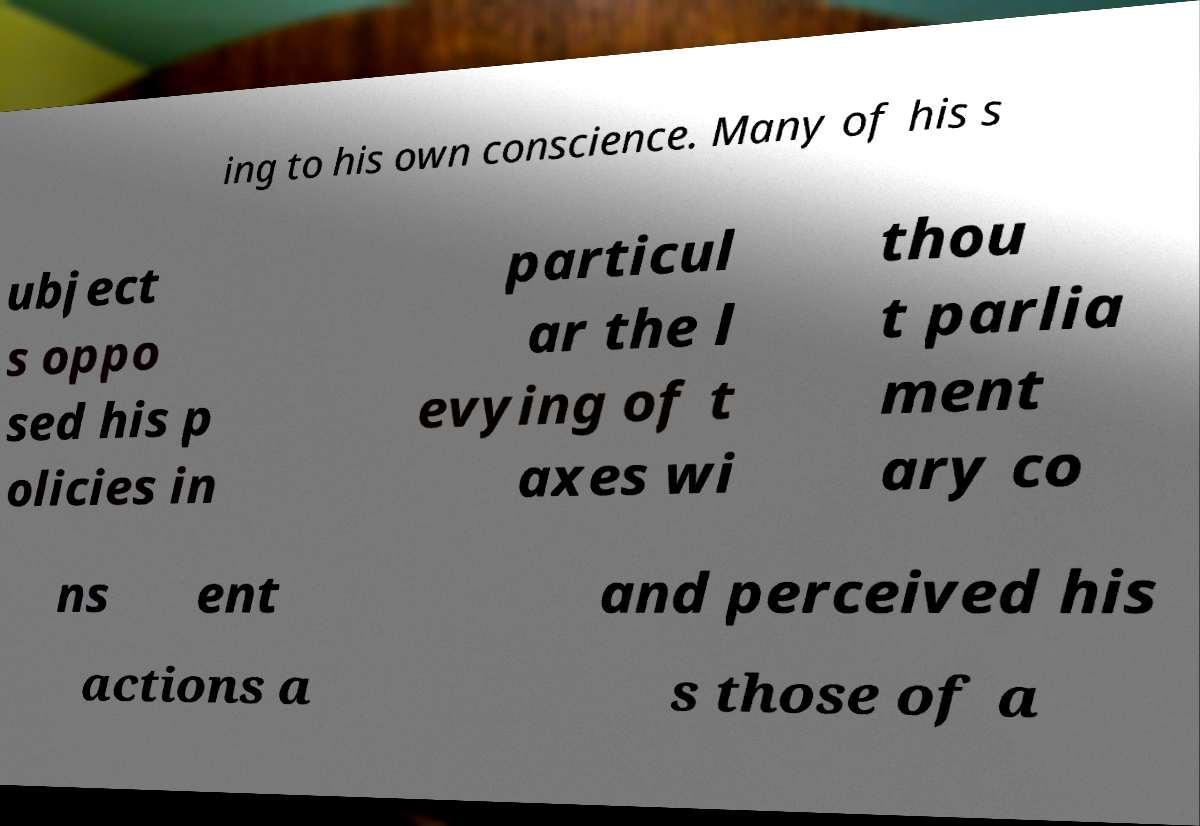There's text embedded in this image that I need extracted. Can you transcribe it verbatim? ing to his own conscience. Many of his s ubject s oppo sed his p olicies in particul ar the l evying of t axes wi thou t parlia ment ary co ns ent and perceived his actions a s those of a 